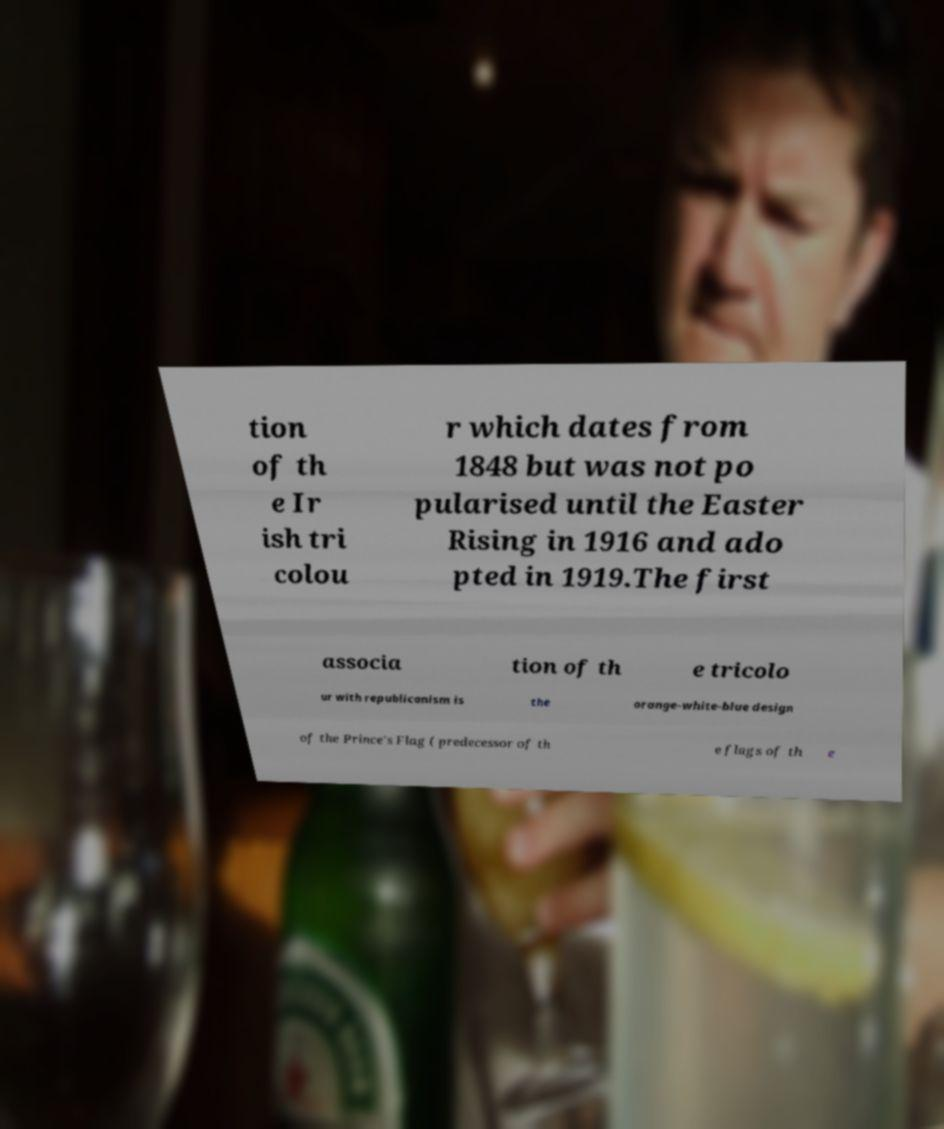There's text embedded in this image that I need extracted. Can you transcribe it verbatim? tion of th e Ir ish tri colou r which dates from 1848 but was not po pularised until the Easter Rising in 1916 and ado pted in 1919.The first associa tion of th e tricolo ur with republicanism is the orange-white-blue design of the Prince's Flag ( predecessor of th e flags of th e 